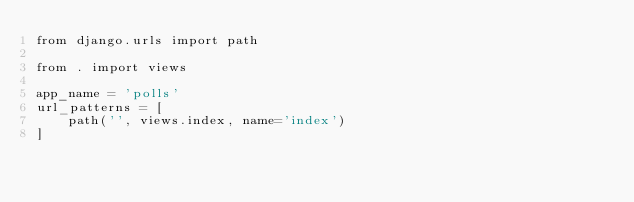<code> <loc_0><loc_0><loc_500><loc_500><_Python_>from django.urls import path

from . import views

app_name = 'polls'
url_patterns = [
    path('', views.index, name='index')
]</code> 